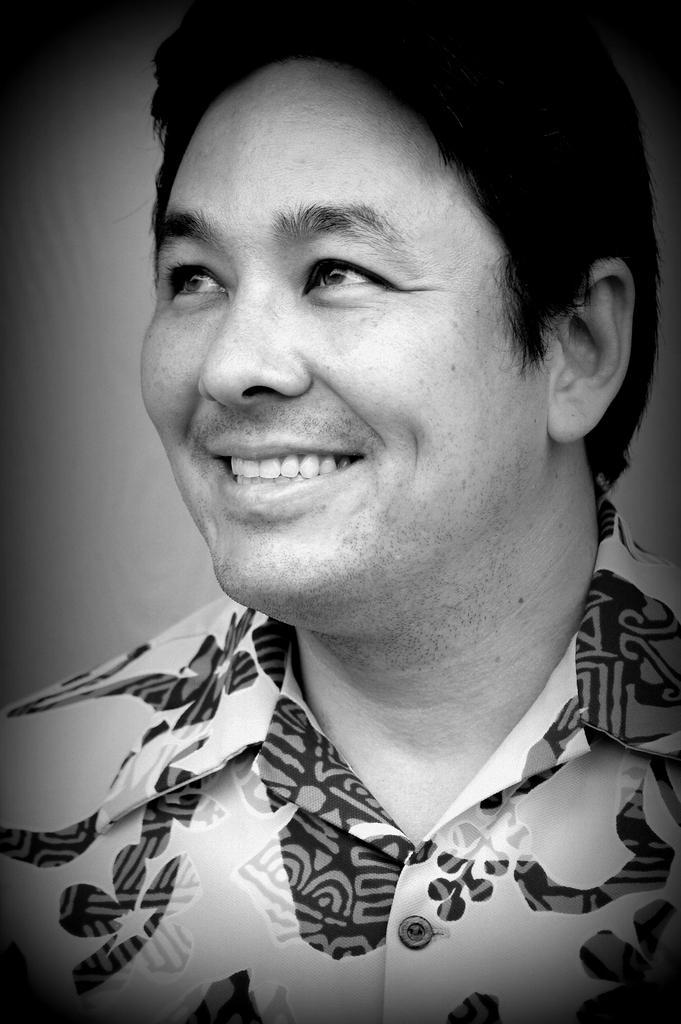Could you give a brief overview of what you see in this image? In this image, we can see a man and he is smiling. 